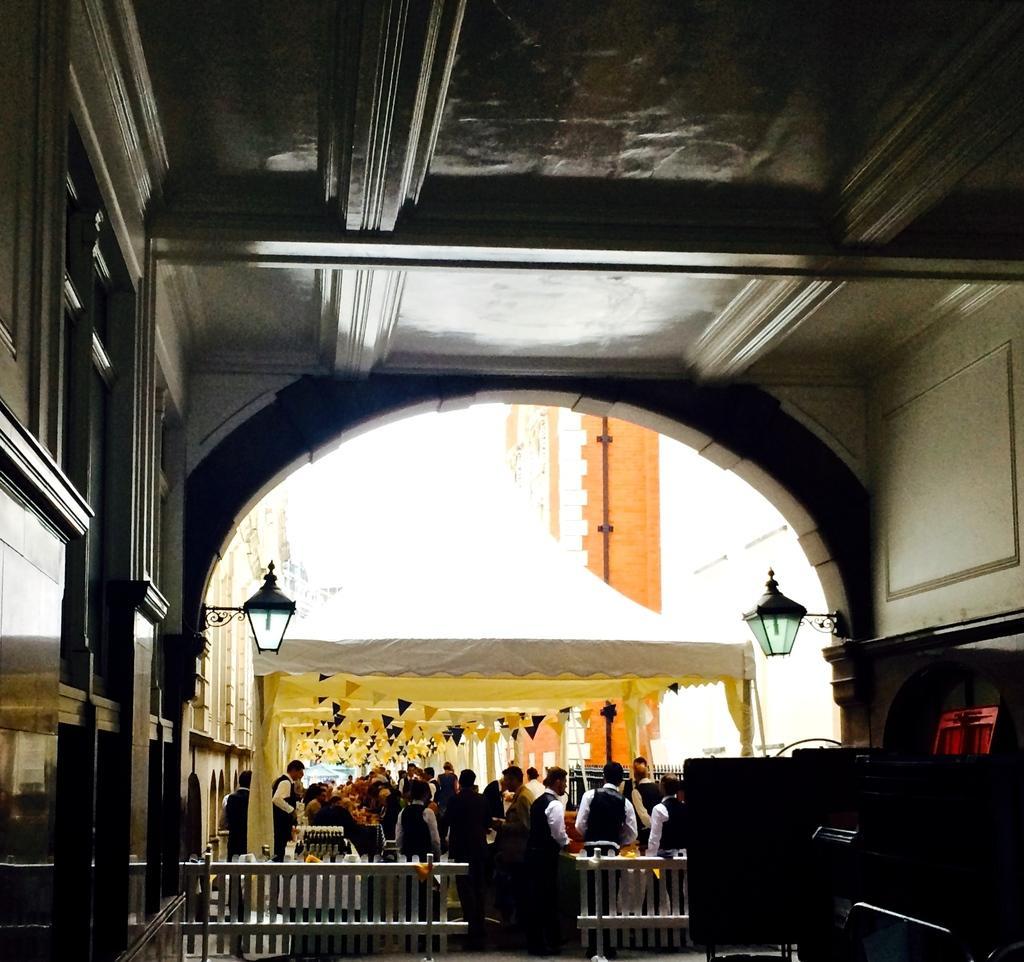Please provide a concise description of this image. In this image, we can see some people and the wall with some objects. We can see the fence and the tent. We can see some flags, a pole and some lights attached to the wall. We can see some objects on the right. 